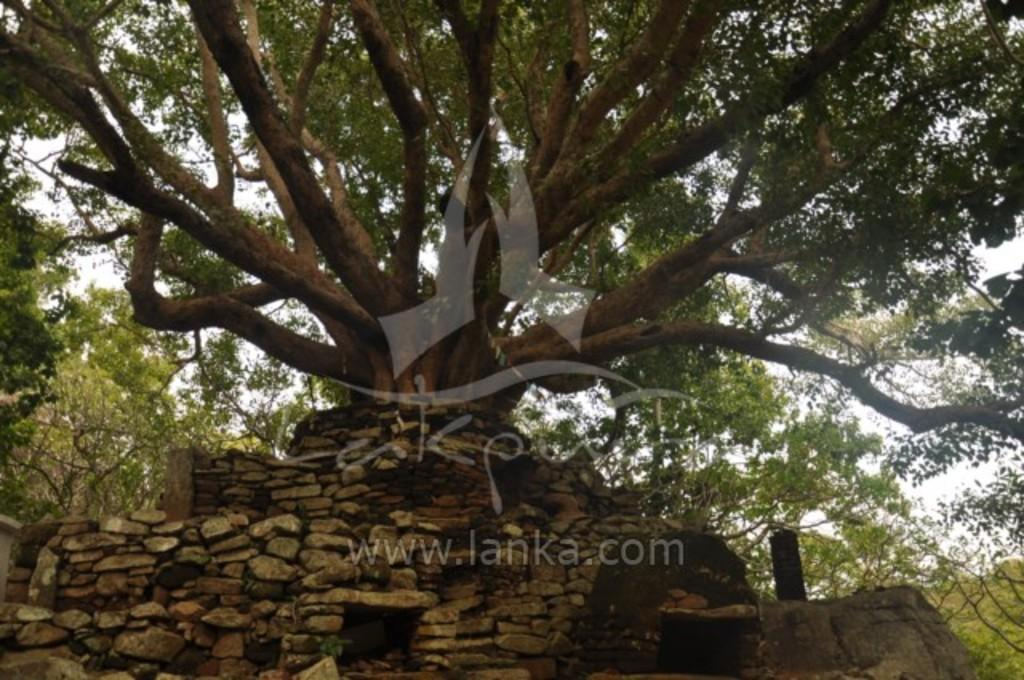What type of natural elements can be seen in the image? There are trees in the image. What man-made structure is present in the image? There is a wall in the image. What part of the natural environment is visible in the image? The sky is visible in the image. What type of information is conveyed through text in the image? There is text on the image, but we cannot determine its content from the provided facts. What type of coat is hanging on the tree in the image? There is no coat present in the image; it only features trees, a wall, and the sky. What type of produce can be seen in the basket in the image? There is no basket or produce present in the image. 